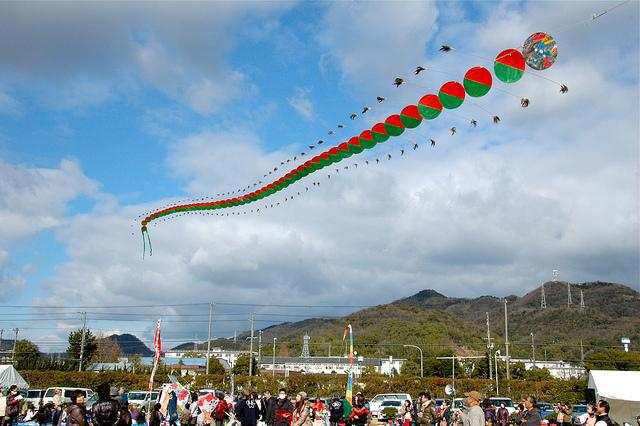Which one of these countries has a flag that is most similar to the kite? portugal 